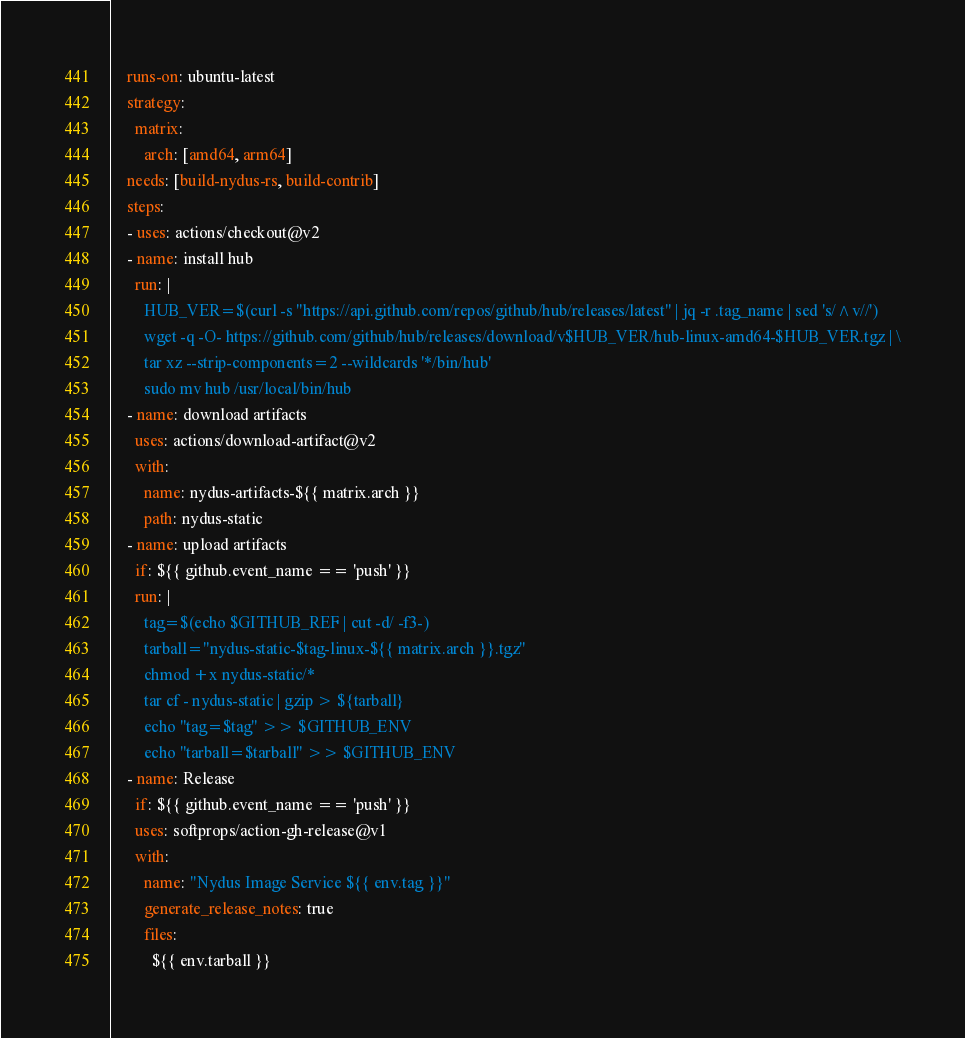Convert code to text. <code><loc_0><loc_0><loc_500><loc_500><_YAML_>    runs-on: ubuntu-latest
    strategy:
      matrix:
        arch: [amd64, arm64]
    needs: [build-nydus-rs, build-contrib]
    steps:
    - uses: actions/checkout@v2
    - name: install hub
      run: |
        HUB_VER=$(curl -s "https://api.github.com/repos/github/hub/releases/latest" | jq -r .tag_name | sed 's/^v//')
        wget -q -O- https://github.com/github/hub/releases/download/v$HUB_VER/hub-linux-amd64-$HUB_VER.tgz | \
        tar xz --strip-components=2 --wildcards '*/bin/hub'
        sudo mv hub /usr/local/bin/hub
    - name: download artifacts
      uses: actions/download-artifact@v2
      with:
        name: nydus-artifacts-${{ matrix.arch }}
        path: nydus-static
    - name: upload artifacts
      if: ${{ github.event_name == 'push' }}
      run: |
        tag=$(echo $GITHUB_REF | cut -d/ -f3-)
        tarball="nydus-static-$tag-linux-${{ matrix.arch }}.tgz"
        chmod +x nydus-static/*
        tar cf - nydus-static | gzip > ${tarball}
        echo "tag=$tag" >> $GITHUB_ENV
        echo "tarball=$tarball" >> $GITHUB_ENV
    - name: Release
      if: ${{ github.event_name == 'push' }}
      uses: softprops/action-gh-release@v1
      with:
        name: "Nydus Image Service ${{ env.tag }}"
        generate_release_notes: true
        files:
          ${{ env.tarball }}
</code> 